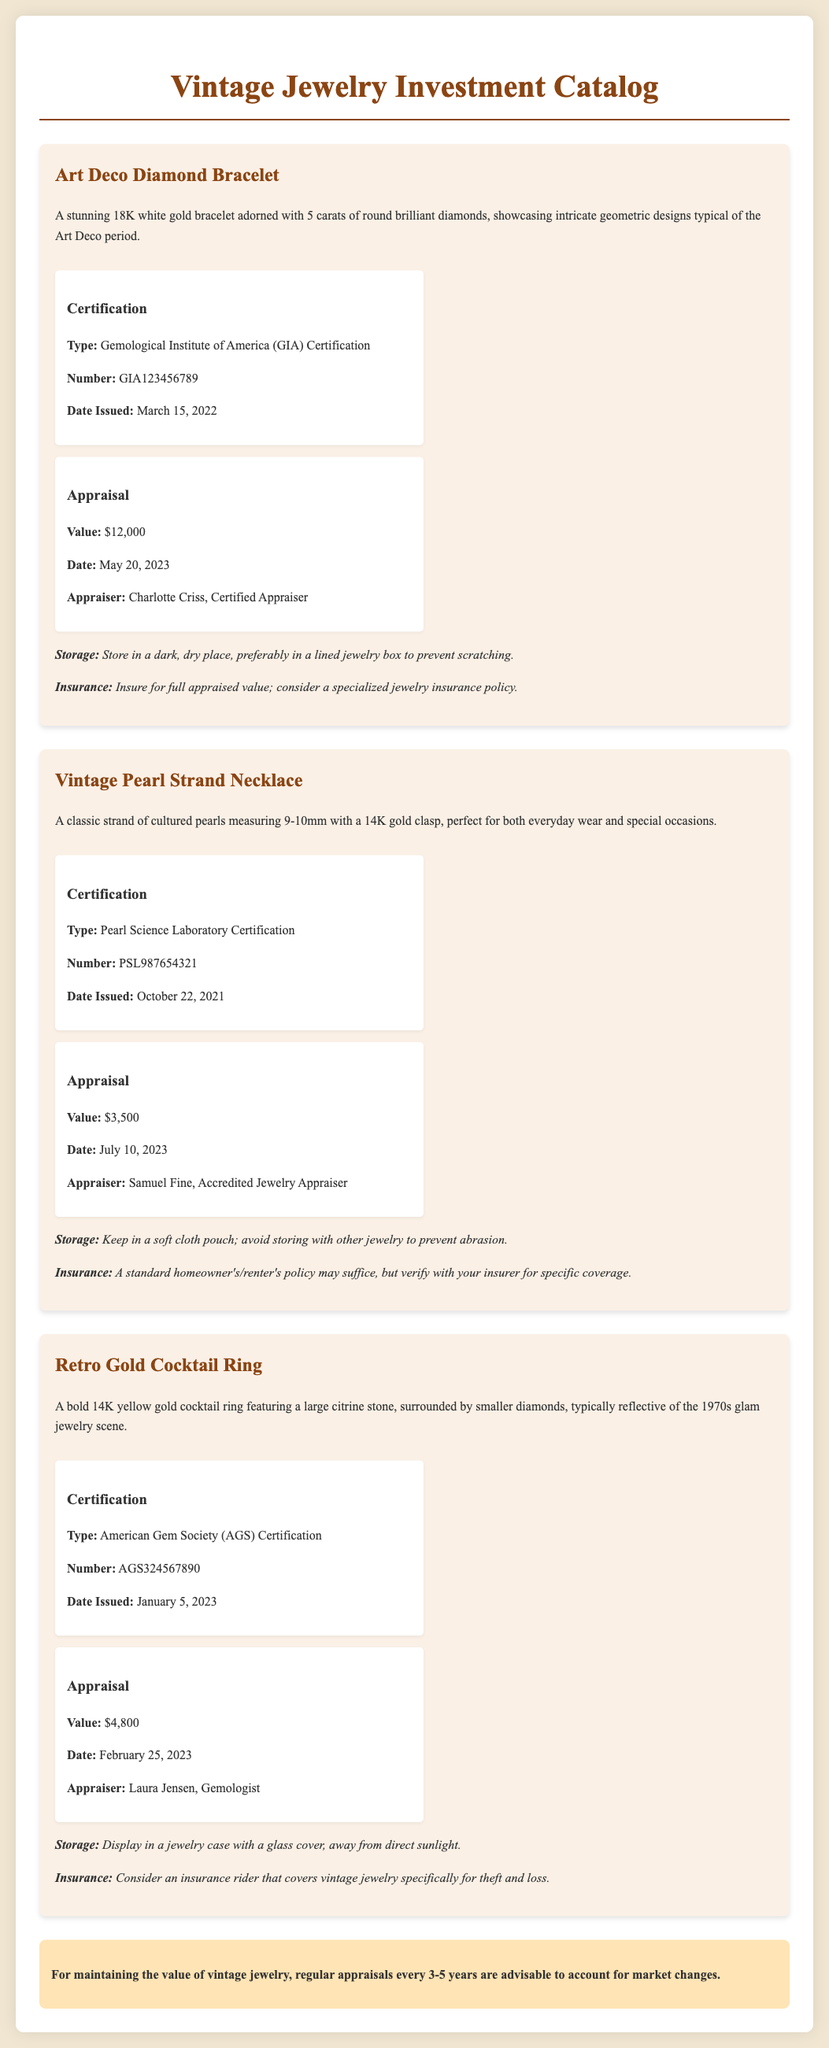What is the title of the catalog? The title of the catalog is stated at the top of the document.
Answer: Vintage Jewelry Investment Catalog What type of certification does the Art Deco Diamond Bracelet have? The certification type is mentioned in the details of the Art Deco Diamond Bracelet.
Answer: Gemological Institute of America (GIA) Certification What is the appraised value of the Vintage Pearl Strand Necklace? The appraised value is listed in the appraisal section for the Vintage Pearl Strand Necklace.
Answer: $3,500 When was the appraisal for the Retro Gold Cocktail Ring completed? The date of the appraisal is included in the appraisal section for the Retro Gold Cocktail Ring.
Answer: February 25, 2023 What recommendations are provided for the storage of the Art Deco Diamond Bracelet? Storage recommendations can be found in the details of the Art Deco Diamond Bracelet.
Answer: Store in a dark, dry place, preferably in a lined jewelry box to prevent scratching What is the date of issue for the certification of the Vintage Pearl Strand Necklace? The date of issue is specified in the certification section of the Vintage Pearl Strand Necklace.
Answer: October 22, 2021 Who was the appraiser for the Art Deco Diamond Bracelet? The appraiser's name is mentioned in the appraisal section for the Art Deco Diamond Bracelet.
Answer: Charlotte Criss, Certified Appraiser How often should vintage jewelry be appraised according to the notes? The notes suggest a specific frequency for appraisals in relation to vintage jewelry.
Answer: Every 3-5 years 